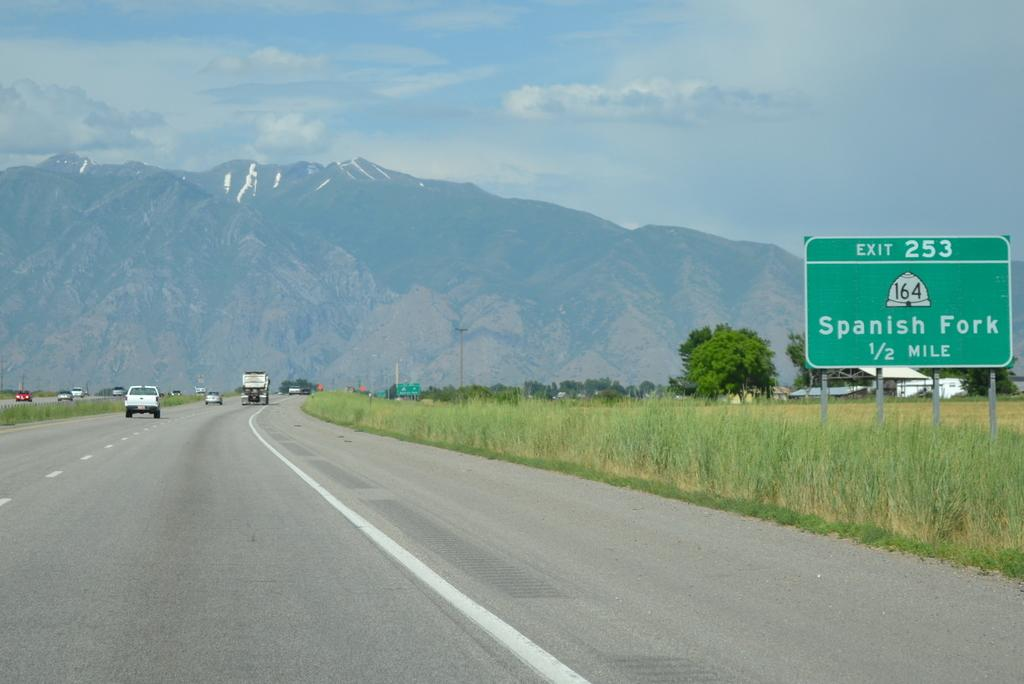<image>
Share a concise interpretation of the image provided. A road with a mountain in the background leads to Spanish Fork. 